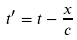Convert formula to latex. <formula><loc_0><loc_0><loc_500><loc_500>t ^ { \prime } = t - \frac { x } { c }</formula> 